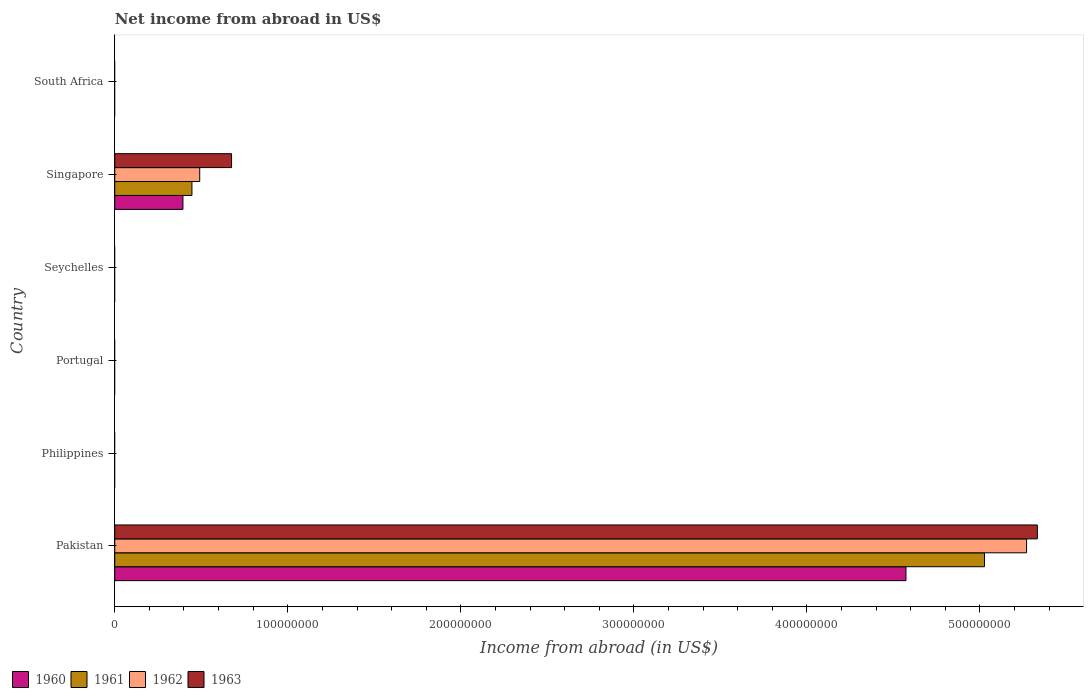Are the number of bars on each tick of the Y-axis equal?
Your response must be concise. No. What is the label of the 4th group of bars from the top?
Make the answer very short. Portugal. In how many cases, is the number of bars for a given country not equal to the number of legend labels?
Your answer should be very brief. 4. What is the net income from abroad in 1960 in Singapore?
Offer a terse response. 3.94e+07. Across all countries, what is the maximum net income from abroad in 1962?
Keep it short and to the point. 5.27e+08. Across all countries, what is the minimum net income from abroad in 1963?
Ensure brevity in your answer.  0. What is the total net income from abroad in 1962 in the graph?
Offer a terse response. 5.76e+08. What is the difference between the net income from abroad in 1963 in Pakistan and that in Singapore?
Ensure brevity in your answer.  4.66e+08. What is the difference between the net income from abroad in 1963 in Portugal and the net income from abroad in 1960 in South Africa?
Provide a succinct answer. 0. What is the average net income from abroad in 1962 per country?
Keep it short and to the point. 9.60e+07. What is the difference between the net income from abroad in 1963 and net income from abroad in 1962 in Singapore?
Your response must be concise. 1.84e+07. In how many countries, is the net income from abroad in 1962 greater than 480000000 US$?
Give a very brief answer. 1. What is the ratio of the net income from abroad in 1961 in Pakistan to that in Singapore?
Provide a succinct answer. 11.27. Is the net income from abroad in 1963 in Pakistan less than that in Singapore?
Offer a very short reply. No. What is the difference between the highest and the lowest net income from abroad in 1960?
Provide a succinct answer. 4.57e+08. Is it the case that in every country, the sum of the net income from abroad in 1962 and net income from abroad in 1961 is greater than the net income from abroad in 1960?
Provide a succinct answer. No. How many bars are there?
Your response must be concise. 8. Are all the bars in the graph horizontal?
Keep it short and to the point. Yes. Are the values on the major ticks of X-axis written in scientific E-notation?
Keep it short and to the point. No. Does the graph contain any zero values?
Keep it short and to the point. Yes. Does the graph contain grids?
Your answer should be very brief. No. Where does the legend appear in the graph?
Provide a short and direct response. Bottom left. How many legend labels are there?
Your response must be concise. 4. What is the title of the graph?
Keep it short and to the point. Net income from abroad in US$. What is the label or title of the X-axis?
Ensure brevity in your answer.  Income from abroad (in US$). What is the label or title of the Y-axis?
Your answer should be very brief. Country. What is the Income from abroad (in US$) in 1960 in Pakistan?
Your answer should be compact. 4.57e+08. What is the Income from abroad (in US$) in 1961 in Pakistan?
Keep it short and to the point. 5.03e+08. What is the Income from abroad (in US$) in 1962 in Pakistan?
Offer a very short reply. 5.27e+08. What is the Income from abroad (in US$) of 1963 in Pakistan?
Provide a succinct answer. 5.33e+08. What is the Income from abroad (in US$) of 1960 in Philippines?
Your answer should be compact. 0. What is the Income from abroad (in US$) of 1961 in Philippines?
Your answer should be very brief. 0. What is the Income from abroad (in US$) of 1960 in Seychelles?
Make the answer very short. 0. What is the Income from abroad (in US$) of 1962 in Seychelles?
Offer a very short reply. 0. What is the Income from abroad (in US$) in 1963 in Seychelles?
Provide a succinct answer. 0. What is the Income from abroad (in US$) in 1960 in Singapore?
Give a very brief answer. 3.94e+07. What is the Income from abroad (in US$) of 1961 in Singapore?
Ensure brevity in your answer.  4.46e+07. What is the Income from abroad (in US$) in 1962 in Singapore?
Make the answer very short. 4.91e+07. What is the Income from abroad (in US$) of 1963 in Singapore?
Make the answer very short. 6.75e+07. What is the Income from abroad (in US$) of 1961 in South Africa?
Offer a terse response. 0. What is the Income from abroad (in US$) of 1962 in South Africa?
Your answer should be very brief. 0. What is the Income from abroad (in US$) of 1963 in South Africa?
Your response must be concise. 0. Across all countries, what is the maximum Income from abroad (in US$) in 1960?
Offer a very short reply. 4.57e+08. Across all countries, what is the maximum Income from abroad (in US$) in 1961?
Ensure brevity in your answer.  5.03e+08. Across all countries, what is the maximum Income from abroad (in US$) in 1962?
Offer a very short reply. 5.27e+08. Across all countries, what is the maximum Income from abroad (in US$) of 1963?
Your response must be concise. 5.33e+08. Across all countries, what is the minimum Income from abroad (in US$) in 1961?
Give a very brief answer. 0. Across all countries, what is the minimum Income from abroad (in US$) of 1962?
Give a very brief answer. 0. What is the total Income from abroad (in US$) of 1960 in the graph?
Provide a short and direct response. 4.97e+08. What is the total Income from abroad (in US$) in 1961 in the graph?
Keep it short and to the point. 5.47e+08. What is the total Income from abroad (in US$) of 1962 in the graph?
Offer a very short reply. 5.76e+08. What is the total Income from abroad (in US$) of 1963 in the graph?
Keep it short and to the point. 6.01e+08. What is the difference between the Income from abroad (in US$) of 1960 in Pakistan and that in Singapore?
Offer a terse response. 4.18e+08. What is the difference between the Income from abroad (in US$) of 1961 in Pakistan and that in Singapore?
Give a very brief answer. 4.58e+08. What is the difference between the Income from abroad (in US$) in 1962 in Pakistan and that in Singapore?
Offer a terse response. 4.78e+08. What is the difference between the Income from abroad (in US$) of 1963 in Pakistan and that in Singapore?
Offer a very short reply. 4.66e+08. What is the difference between the Income from abroad (in US$) in 1960 in Pakistan and the Income from abroad (in US$) in 1961 in Singapore?
Offer a terse response. 4.13e+08. What is the difference between the Income from abroad (in US$) of 1960 in Pakistan and the Income from abroad (in US$) of 1962 in Singapore?
Provide a succinct answer. 4.08e+08. What is the difference between the Income from abroad (in US$) of 1960 in Pakistan and the Income from abroad (in US$) of 1963 in Singapore?
Your answer should be very brief. 3.90e+08. What is the difference between the Income from abroad (in US$) of 1961 in Pakistan and the Income from abroad (in US$) of 1962 in Singapore?
Keep it short and to the point. 4.54e+08. What is the difference between the Income from abroad (in US$) in 1961 in Pakistan and the Income from abroad (in US$) in 1963 in Singapore?
Your answer should be very brief. 4.35e+08. What is the difference between the Income from abroad (in US$) in 1962 in Pakistan and the Income from abroad (in US$) in 1963 in Singapore?
Ensure brevity in your answer.  4.59e+08. What is the average Income from abroad (in US$) of 1960 per country?
Provide a short and direct response. 8.28e+07. What is the average Income from abroad (in US$) in 1961 per country?
Your answer should be compact. 9.12e+07. What is the average Income from abroad (in US$) in 1962 per country?
Keep it short and to the point. 9.60e+07. What is the average Income from abroad (in US$) in 1963 per country?
Your answer should be compact. 1.00e+08. What is the difference between the Income from abroad (in US$) of 1960 and Income from abroad (in US$) of 1961 in Pakistan?
Provide a succinct answer. -4.54e+07. What is the difference between the Income from abroad (in US$) of 1960 and Income from abroad (in US$) of 1962 in Pakistan?
Give a very brief answer. -6.97e+07. What is the difference between the Income from abroad (in US$) of 1960 and Income from abroad (in US$) of 1963 in Pakistan?
Your answer should be compact. -7.59e+07. What is the difference between the Income from abroad (in US$) in 1961 and Income from abroad (in US$) in 1962 in Pakistan?
Offer a terse response. -2.43e+07. What is the difference between the Income from abroad (in US$) in 1961 and Income from abroad (in US$) in 1963 in Pakistan?
Your answer should be very brief. -3.06e+07. What is the difference between the Income from abroad (in US$) of 1962 and Income from abroad (in US$) of 1963 in Pakistan?
Your answer should be compact. -6.23e+06. What is the difference between the Income from abroad (in US$) of 1960 and Income from abroad (in US$) of 1961 in Singapore?
Keep it short and to the point. -5.20e+06. What is the difference between the Income from abroad (in US$) in 1960 and Income from abroad (in US$) in 1962 in Singapore?
Your answer should be compact. -9.70e+06. What is the difference between the Income from abroad (in US$) in 1960 and Income from abroad (in US$) in 1963 in Singapore?
Keep it short and to the point. -2.81e+07. What is the difference between the Income from abroad (in US$) in 1961 and Income from abroad (in US$) in 1962 in Singapore?
Give a very brief answer. -4.50e+06. What is the difference between the Income from abroad (in US$) of 1961 and Income from abroad (in US$) of 1963 in Singapore?
Give a very brief answer. -2.29e+07. What is the difference between the Income from abroad (in US$) in 1962 and Income from abroad (in US$) in 1963 in Singapore?
Your response must be concise. -1.84e+07. What is the ratio of the Income from abroad (in US$) in 1960 in Pakistan to that in Singapore?
Your response must be concise. 11.61. What is the ratio of the Income from abroad (in US$) of 1961 in Pakistan to that in Singapore?
Keep it short and to the point. 11.27. What is the ratio of the Income from abroad (in US$) of 1962 in Pakistan to that in Singapore?
Ensure brevity in your answer.  10.73. What is the ratio of the Income from abroad (in US$) of 1963 in Pakistan to that in Singapore?
Keep it short and to the point. 7.9. What is the difference between the highest and the lowest Income from abroad (in US$) of 1960?
Your answer should be very brief. 4.57e+08. What is the difference between the highest and the lowest Income from abroad (in US$) of 1961?
Keep it short and to the point. 5.03e+08. What is the difference between the highest and the lowest Income from abroad (in US$) in 1962?
Your answer should be very brief. 5.27e+08. What is the difference between the highest and the lowest Income from abroad (in US$) in 1963?
Offer a very short reply. 5.33e+08. 